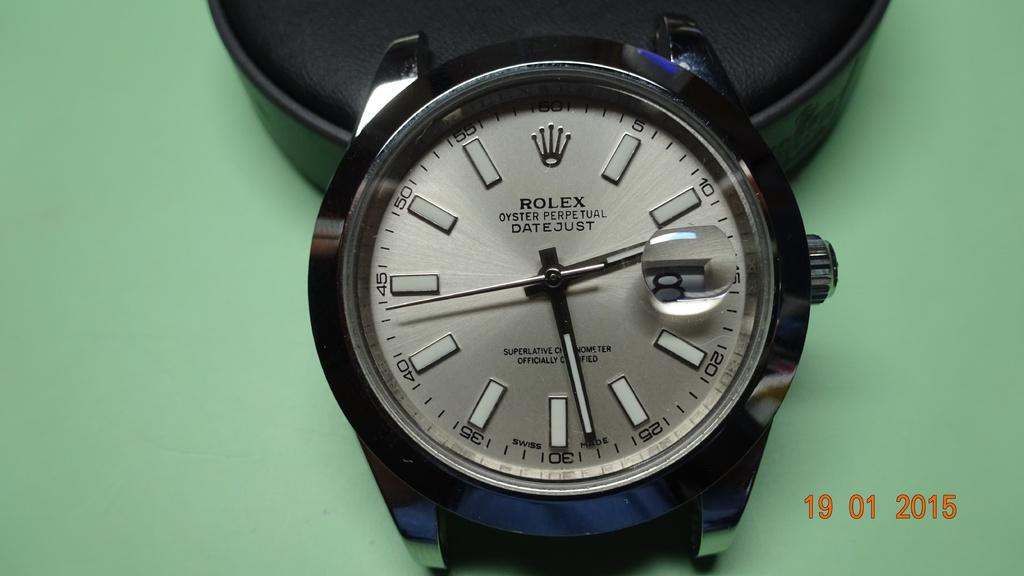<image>
Present a compact description of the photo's key features. a rolex watch with no numbers has a silver face 